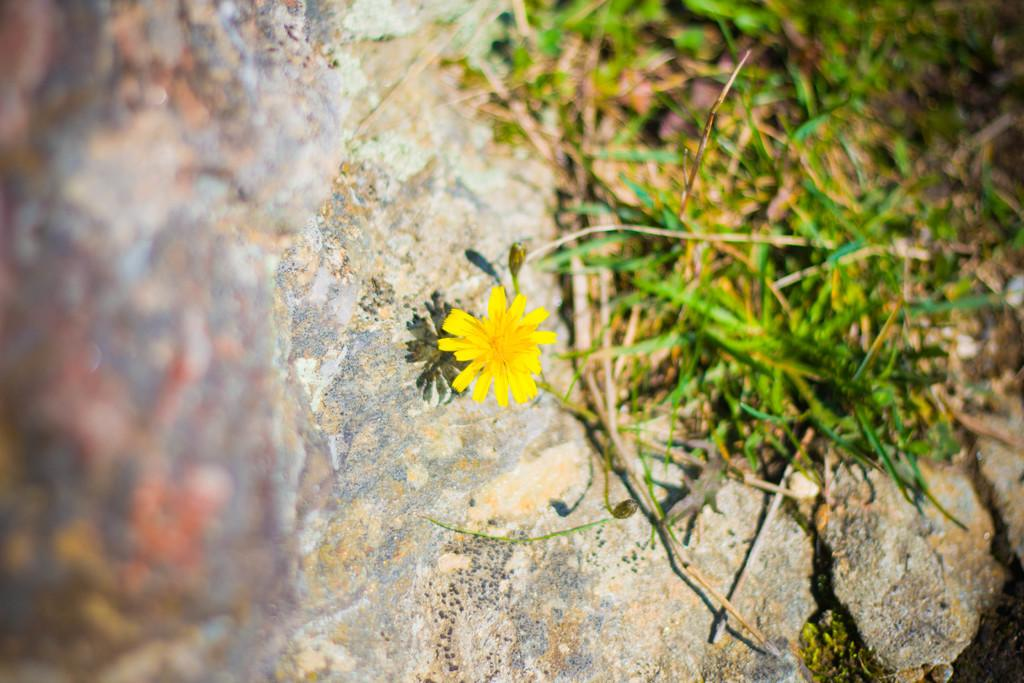What is the main object in the image? There is a rock in the image. What type of vegetation is on the right side of the image? There is grass on the right side of the image. Can you describe the flower in the image? There is a yellow flower with yellow petals in the image. How would you describe the left side of the image? The left side of the image is blurred. What year is depicted in the image? There is no indication of a specific year in the image. Can you describe the woman in the image? There is no woman present in the image. What type of jewel can be seen on the rock in the image? There is no jewel present on the rock in the image. 